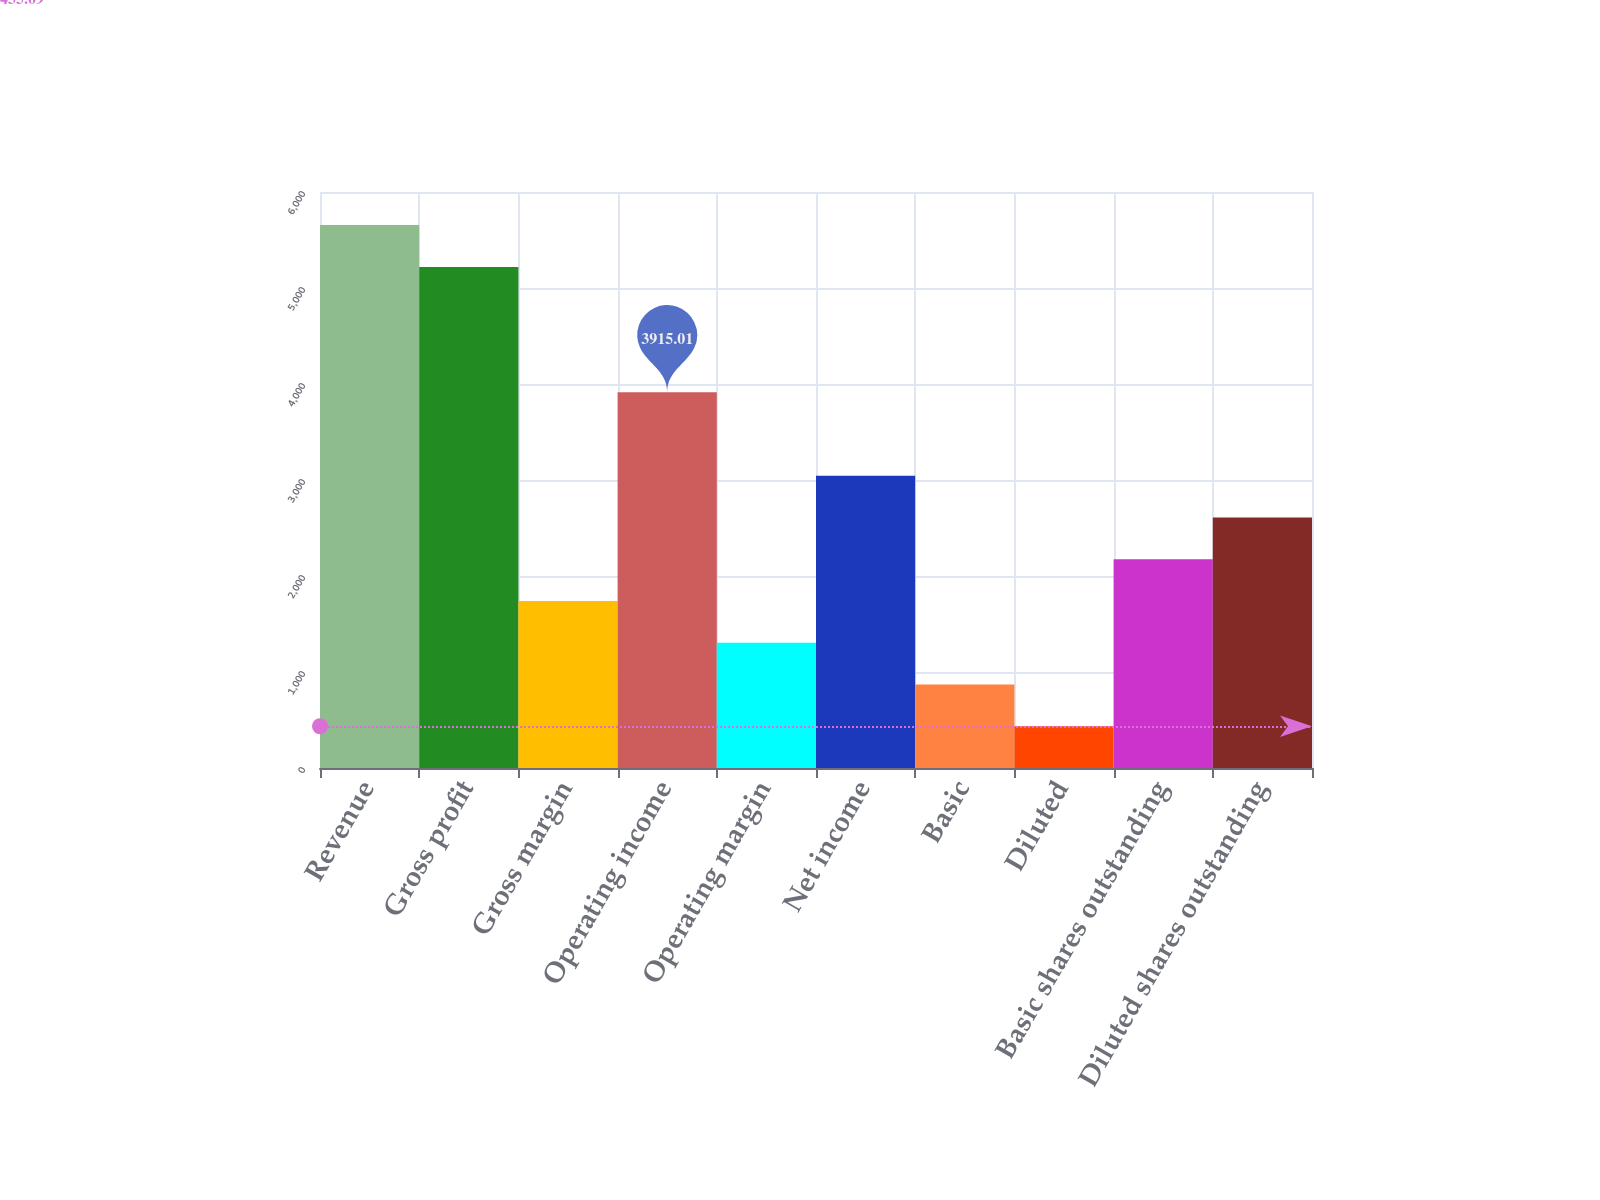Convert chart. <chart><loc_0><loc_0><loc_500><loc_500><bar_chart><fcel>Revenue<fcel>Gross profit<fcel>Gross margin<fcel>Operating income<fcel>Operating margin<fcel>Net income<fcel>Basic<fcel>Diluted<fcel>Basic shares outstanding<fcel>Diluted shares outstanding<nl><fcel>5654.97<fcel>5219.98<fcel>1740.06<fcel>3915.01<fcel>1305.07<fcel>3045.03<fcel>870.08<fcel>435.09<fcel>2175.05<fcel>2610.04<nl></chart> 